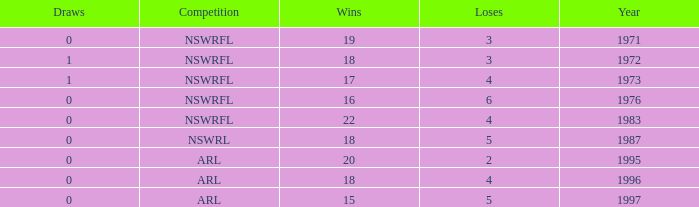What average Wins has Losses 2, and Draws less than 0? None. 